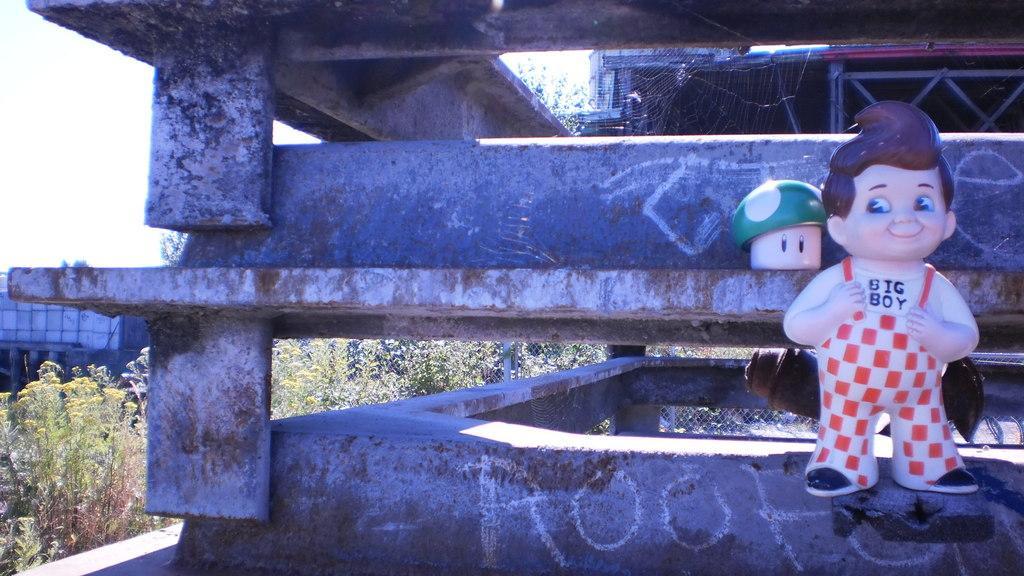Please provide a concise description of this image. In this image, we can see buildings and there are toys, a mesh and we can see a web and some rods and there are trees. 